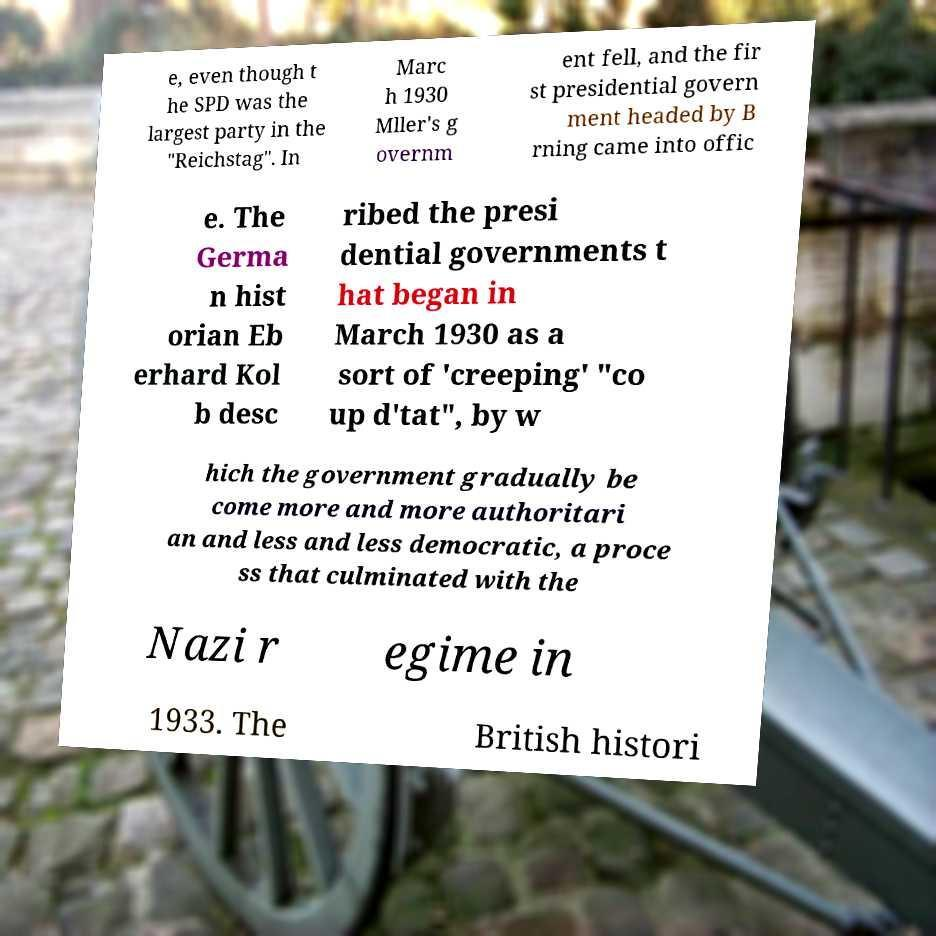Please identify and transcribe the text found in this image. e, even though t he SPD was the largest party in the "Reichstag". In Marc h 1930 Mller's g overnm ent fell, and the fir st presidential govern ment headed by B rning came into offic e. The Germa n hist orian Eb erhard Kol b desc ribed the presi dential governments t hat began in March 1930 as a sort of 'creeping' "co up d'tat", by w hich the government gradually be come more and more authoritari an and less and less democratic, a proce ss that culminated with the Nazi r egime in 1933. The British histori 